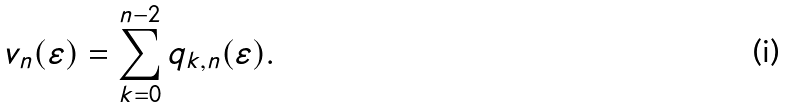<formula> <loc_0><loc_0><loc_500><loc_500>v _ { n } ( \varepsilon ) = \sum _ { k = 0 } ^ { n - 2 } q _ { k , n } ( \varepsilon ) .</formula> 